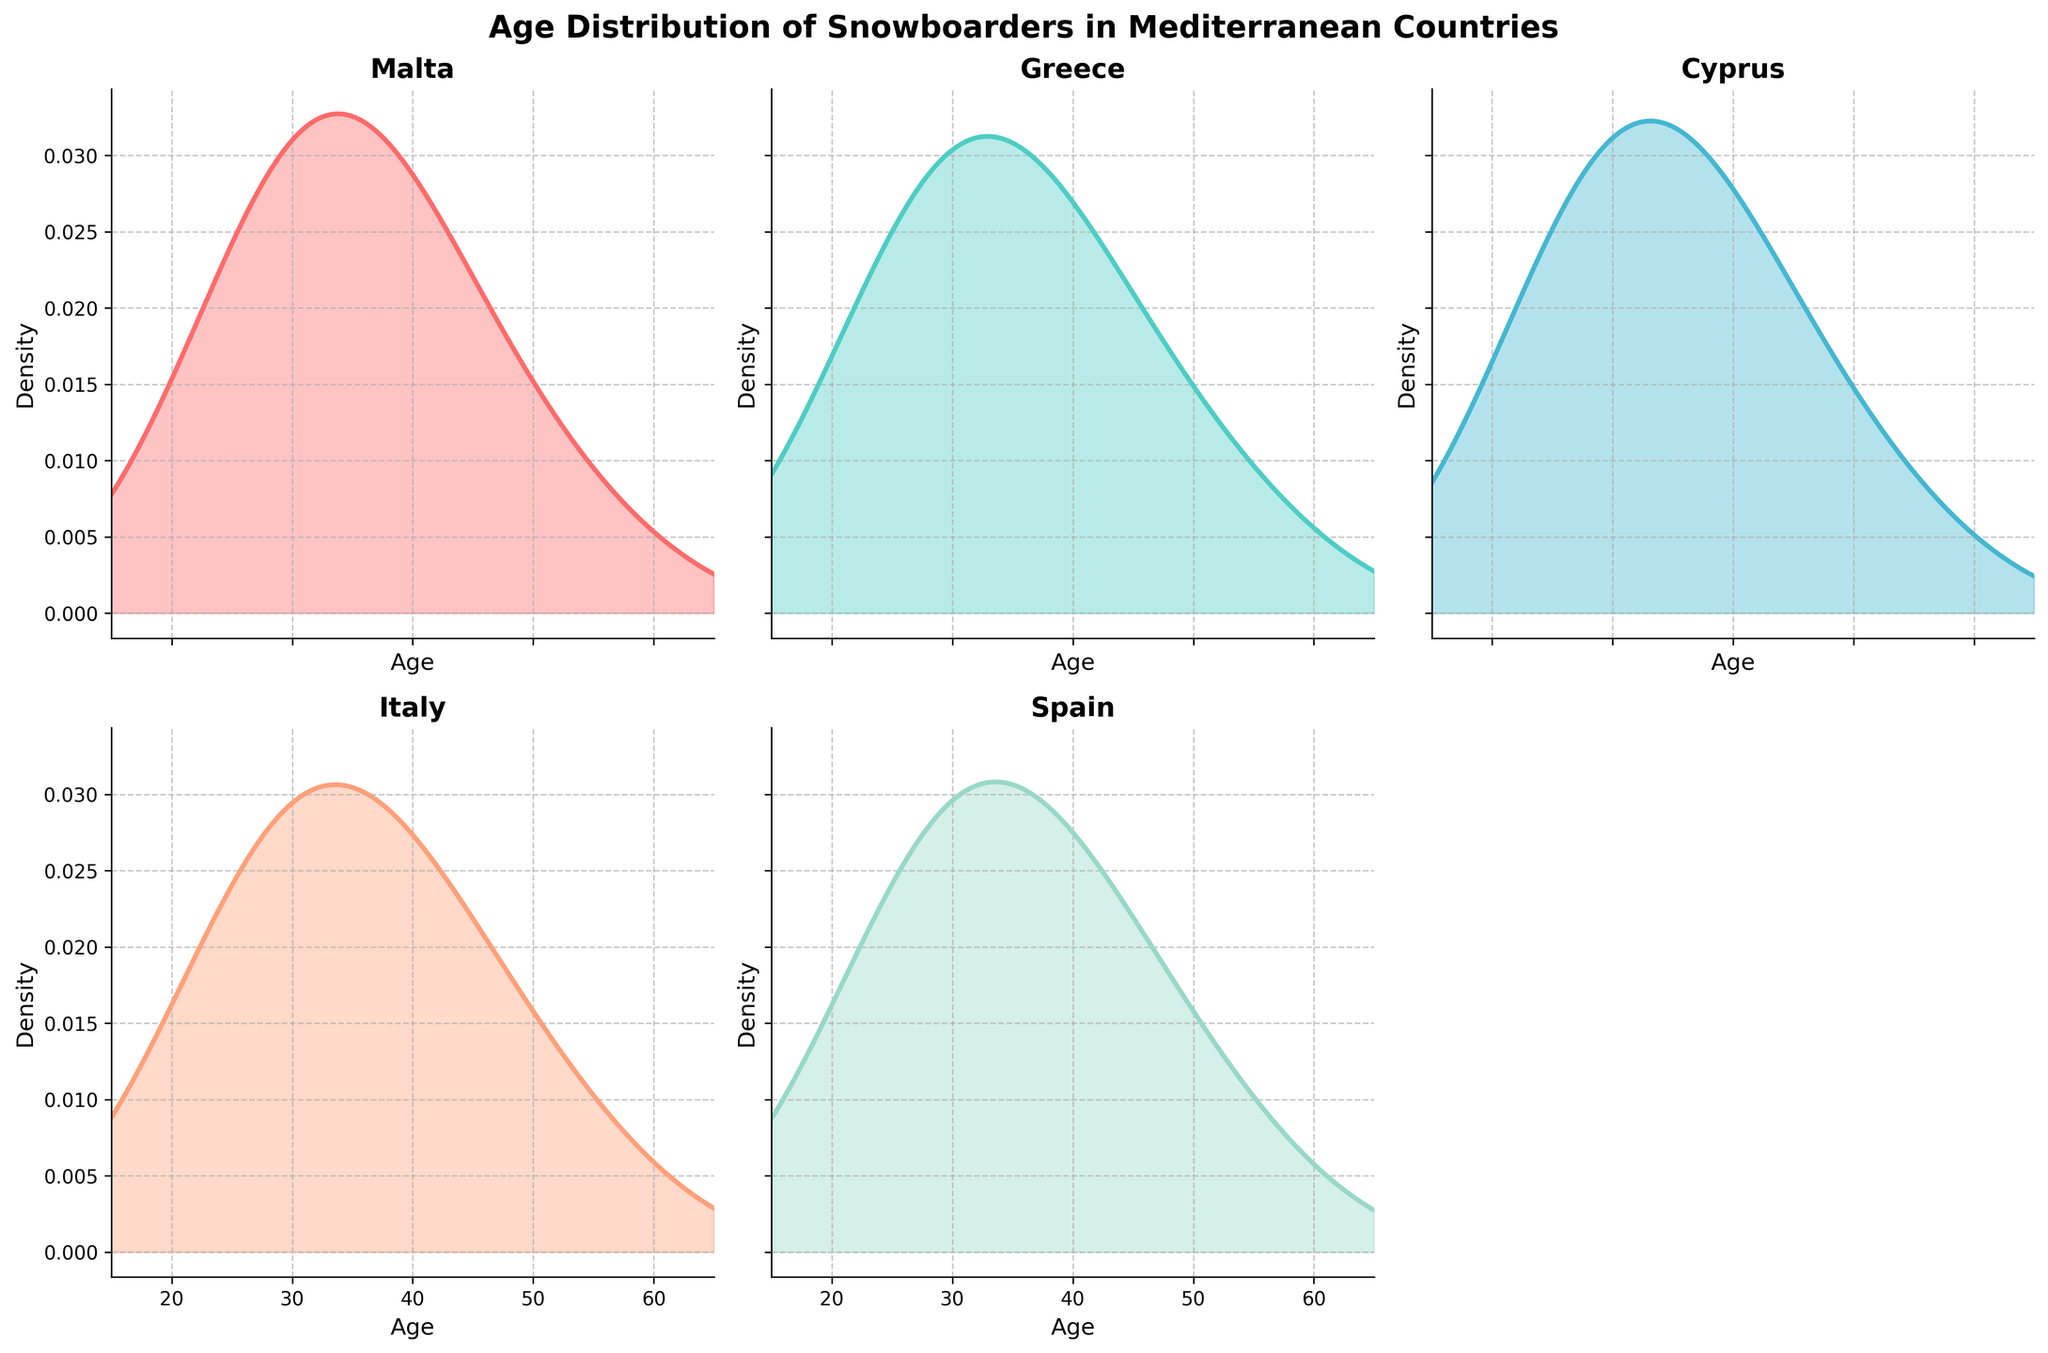What is the title of the figure? The title is written at the top of the figure in a bold font and indicates the overall theme of the plot.
Answer: Age Distribution of Snowboarders in Mediterranean Countries How many countries are compared in the figure? There are individual density plots for Malta, Greece, Cyprus, Italy, and Spain, which means 5 countries are compared.
Answer: 5 Which country has the highest density of snowboarders in the 25 to 32 age range? By examining the density plots, the peak is highest for Italy in this age range.
Answer: Italy In which country's plot does the density of snowboarders decline the most rapidly after the age of 39? The density plot for Spain shows a sharp decline after the age of 39.
Answer: Spain How does the density of snowboarders aged 18 compare between Malta and Greece? By looking at the density plots, Greece has a higher density for snowboarders aged 18 compared to Malta.
Answer: Greece Which country shows the broadest distribution of snowboarder ages? Italy has the broadest range with significant density starting from age 18 up to 53.
Answer: Italy What can you infer about the popularity of snowboarding among older individuals (ages 46 and above) in Malta compared to Spain? Both countries have low density in this age range, but Malta's density at ages 46 and above is slightly less than Spain's.
Answer: Snowboarding is slightly less popular among older individuals in Malta than in Spain In which country is the density of snowboarders aged 25 the highest? The density plot for Italy shows the highest peak at age 25 compared to other countries.
Answer: Italy Is there any country where the density of snowboarders increases continuously as age progresses from 18 to 39? In all density plots, no country shows a continuous increase; they typically peak around age 25 to 32 and then decline.
Answer: No How do the density curves of Malta and Cyprus compare overall? The density curves for Malta and Cyprus are similar, both peaking around age 32 and gradually declining after that.
Answer: Similar Which country has a higher density for snowboarders aged 60, Malta or Greece? The density plot shows Greece has a slightly higher density for snowboarders aged 60 compared to Malta.
Answer: Greece 